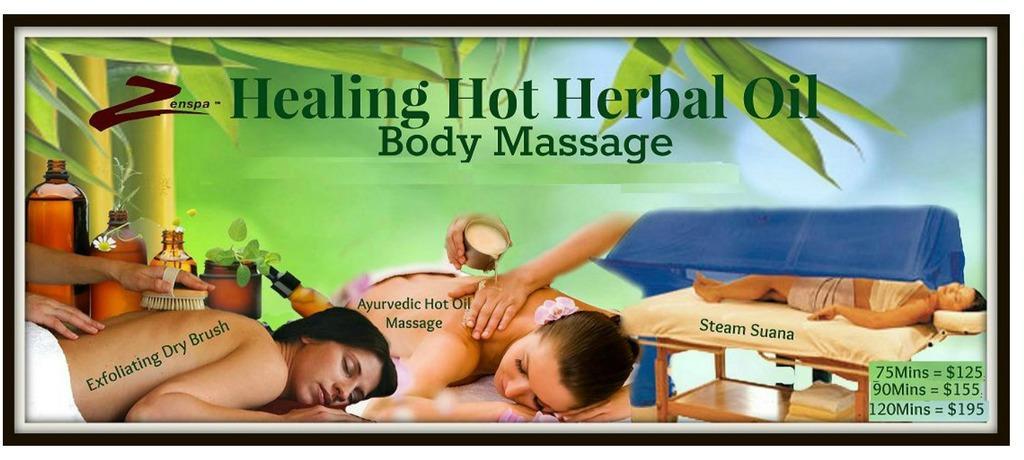Describe this image in one or two sentences. In this image I can see two people are sleeping and one person is sleeping on the bed. I can see few bottles, plants and something is written on the image. I can see the person is holding the brush and another person is holding the glass and I can see few clothes on the wooden surface. Background is in green color. 